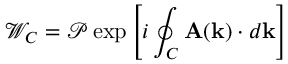Convert formula to latex. <formula><loc_0><loc_0><loc_500><loc_500>\mathcal { W } _ { C } = \mathcal { P } \exp \left [ i \oint _ { C } A ( k ) \cdot d k \right ]</formula> 